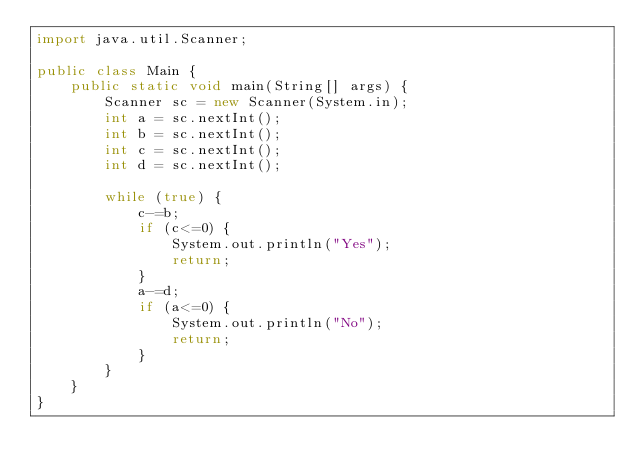<code> <loc_0><loc_0><loc_500><loc_500><_Java_>import java.util.Scanner;

public class Main {
    public static void main(String[] args) {
        Scanner sc = new Scanner(System.in);
        int a = sc.nextInt();
        int b = sc.nextInt();
        int c = sc.nextInt();
        int d = sc.nextInt();

        while (true) {
            c-=b;
            if (c<=0) {
                System.out.println("Yes");
                return;
            }
            a-=d;
            if (a<=0) {
                System.out.println("No");
                return;
            }
        }
    }
}
</code> 